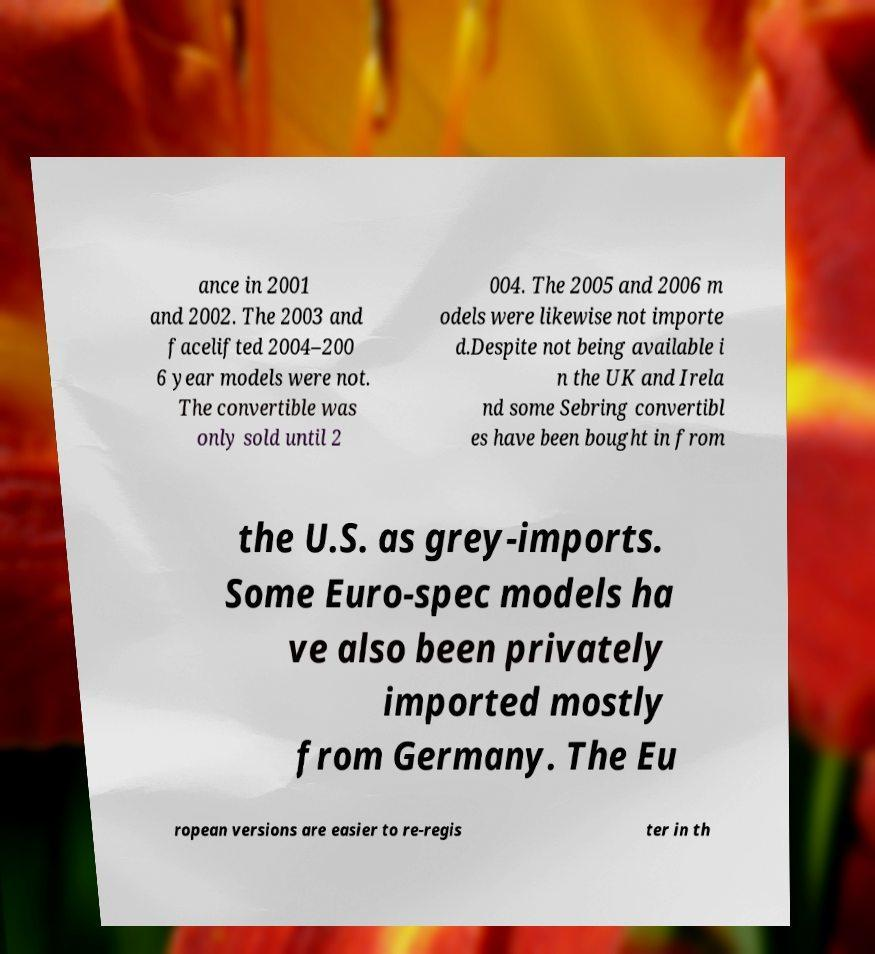Can you read and provide the text displayed in the image?This photo seems to have some interesting text. Can you extract and type it out for me? ance in 2001 and 2002. The 2003 and facelifted 2004–200 6 year models were not. The convertible was only sold until 2 004. The 2005 and 2006 m odels were likewise not importe d.Despite not being available i n the UK and Irela nd some Sebring convertibl es have been bought in from the U.S. as grey-imports. Some Euro-spec models ha ve also been privately imported mostly from Germany. The Eu ropean versions are easier to re-regis ter in th 